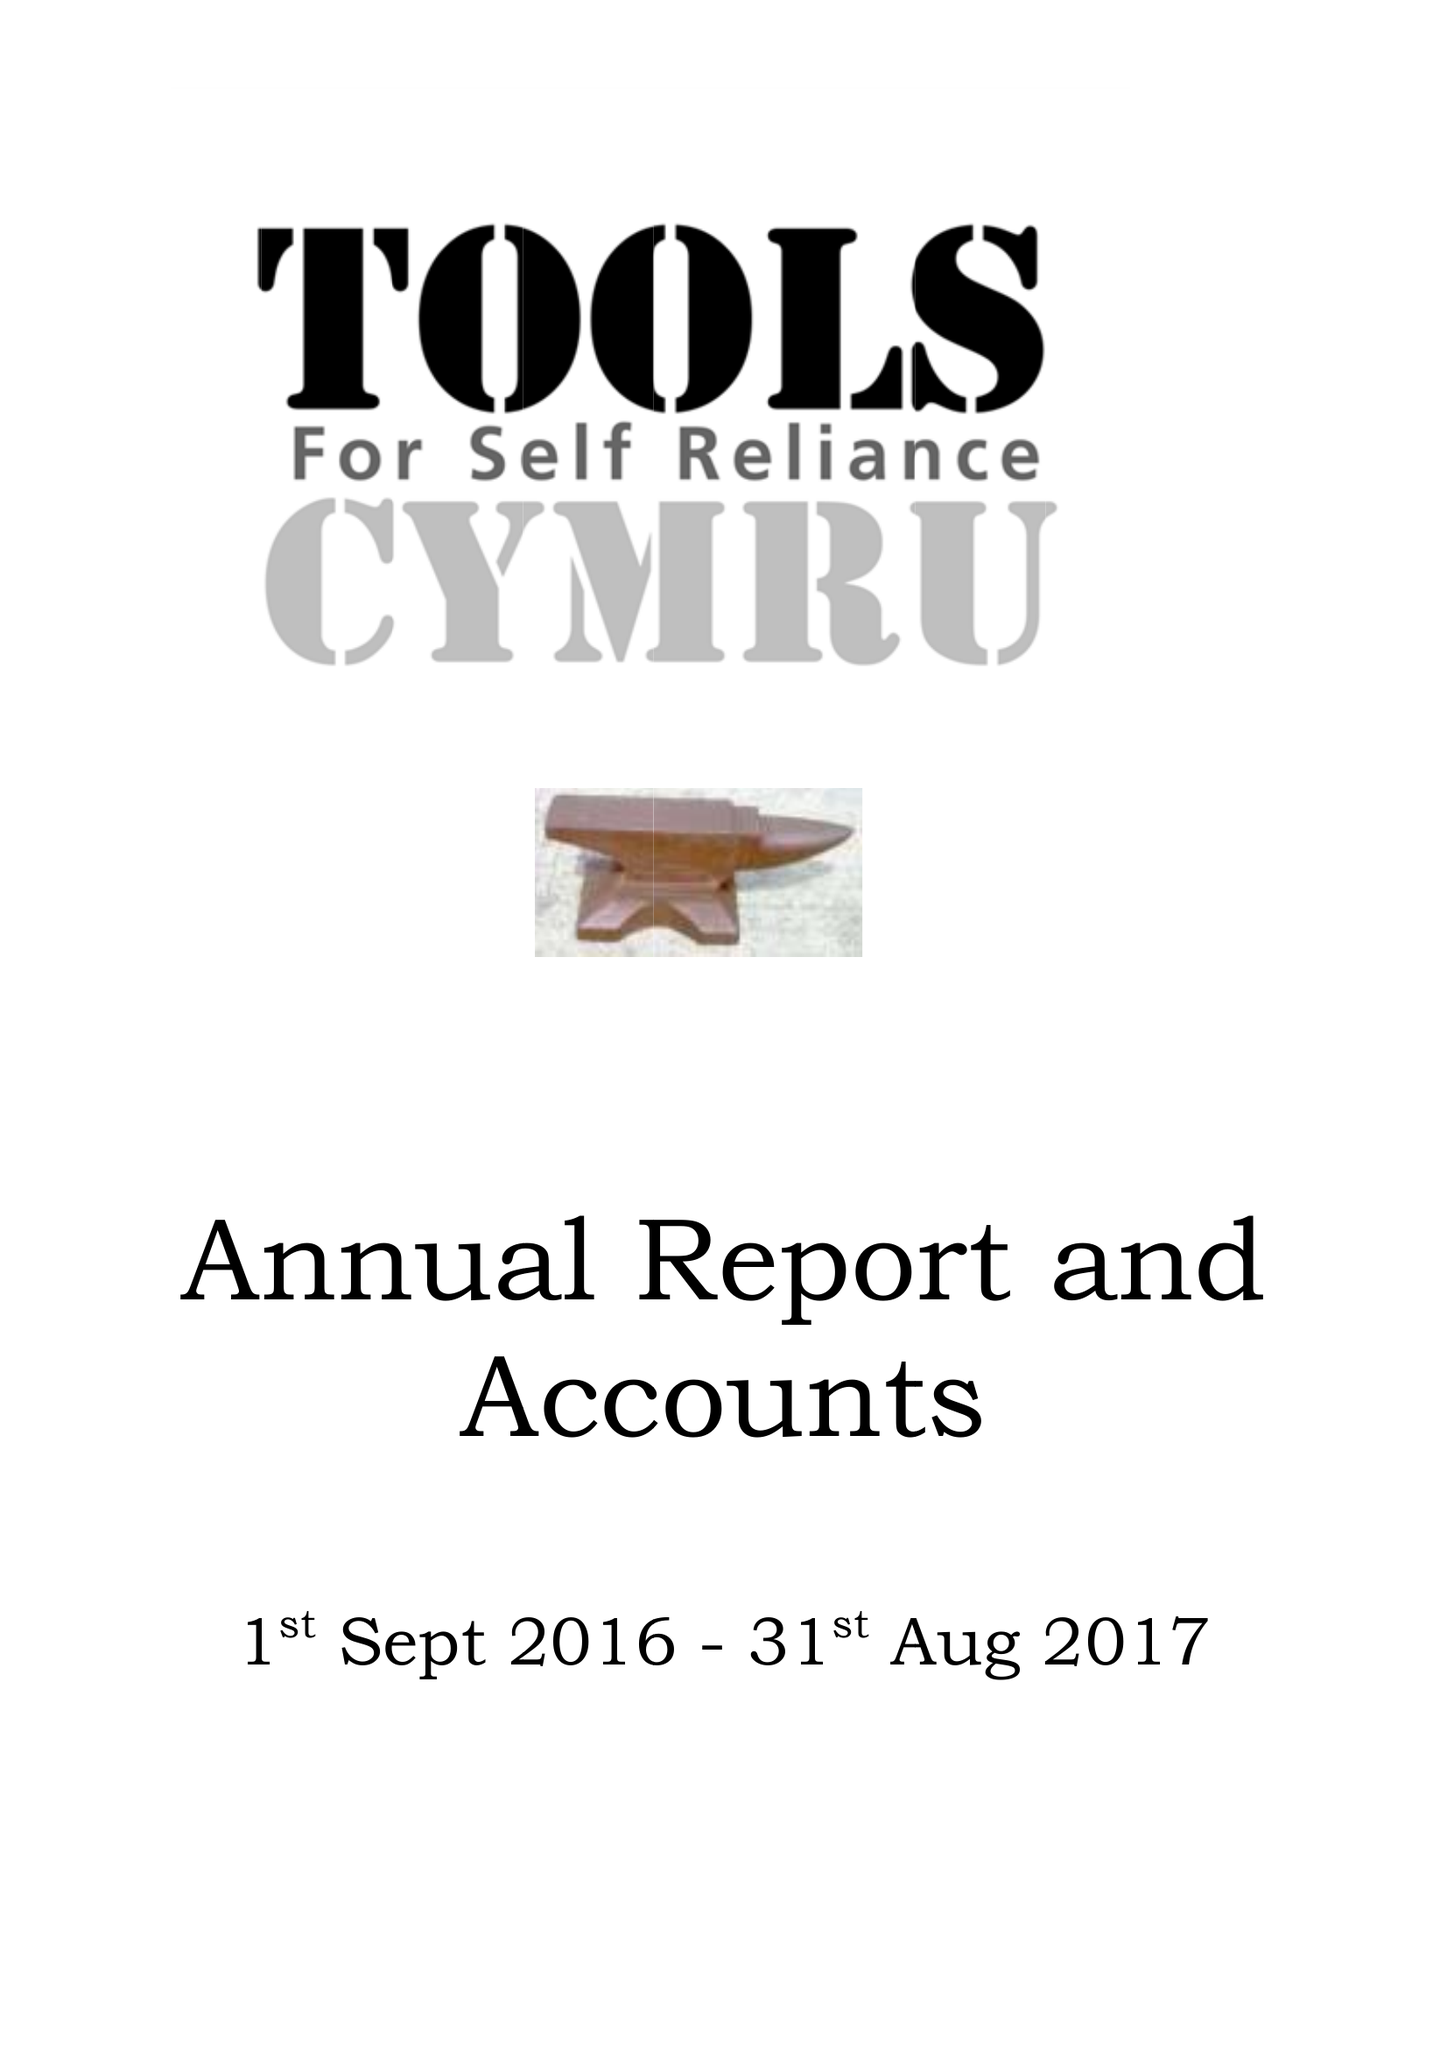What is the value for the address__post_town?
Answer the question using a single word or phrase. None 